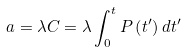Convert formula to latex. <formula><loc_0><loc_0><loc_500><loc_500>a = \lambda C = \lambda \int _ { 0 } ^ { t } P \left ( t ^ { \prime } \right ) d t ^ { \prime }</formula> 